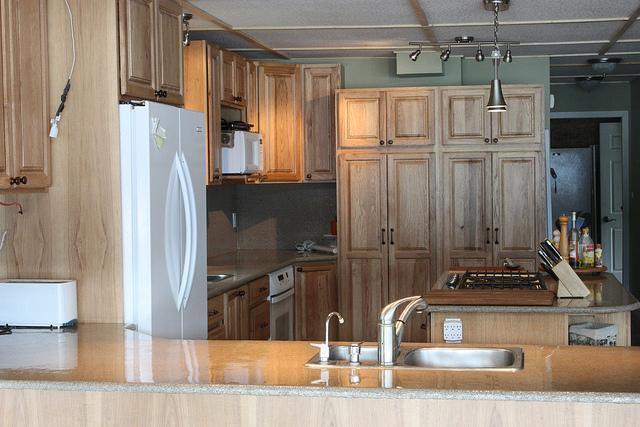How many giraffes are there?
Give a very brief answer. 0. 